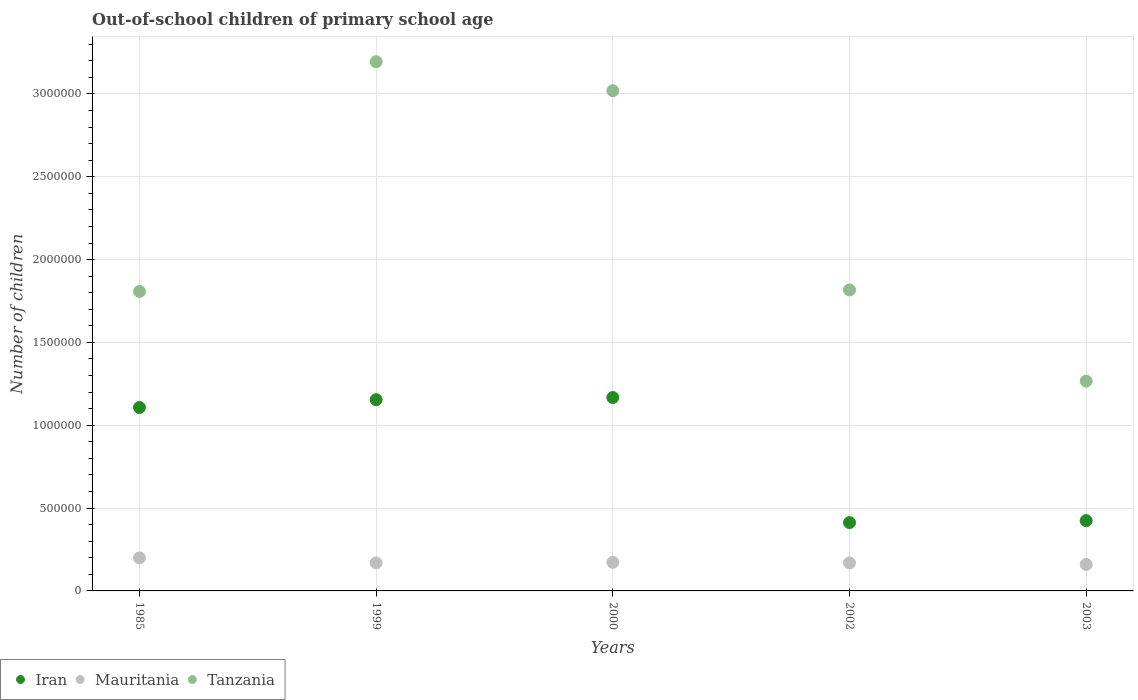How many different coloured dotlines are there?
Offer a very short reply. 3. What is the number of out-of-school children in Mauritania in 2000?
Make the answer very short. 1.73e+05. Across all years, what is the maximum number of out-of-school children in Iran?
Your response must be concise. 1.17e+06. Across all years, what is the minimum number of out-of-school children in Tanzania?
Offer a terse response. 1.27e+06. In which year was the number of out-of-school children in Tanzania maximum?
Your response must be concise. 1999. In which year was the number of out-of-school children in Iran minimum?
Give a very brief answer. 2002. What is the total number of out-of-school children in Mauritania in the graph?
Keep it short and to the point. 8.70e+05. What is the difference between the number of out-of-school children in Iran in 1985 and that in 2002?
Offer a very short reply. 6.95e+05. What is the difference between the number of out-of-school children in Tanzania in 1985 and the number of out-of-school children in Iran in 2002?
Give a very brief answer. 1.40e+06. What is the average number of out-of-school children in Mauritania per year?
Your answer should be compact. 1.74e+05. In the year 2002, what is the difference between the number of out-of-school children in Tanzania and number of out-of-school children in Iran?
Your response must be concise. 1.40e+06. In how many years, is the number of out-of-school children in Tanzania greater than 300000?
Make the answer very short. 5. What is the ratio of the number of out-of-school children in Mauritania in 1985 to that in 2002?
Your answer should be compact. 1.18. Is the difference between the number of out-of-school children in Tanzania in 1985 and 2002 greater than the difference between the number of out-of-school children in Iran in 1985 and 2002?
Provide a short and direct response. No. What is the difference between the highest and the second highest number of out-of-school children in Tanzania?
Give a very brief answer. 1.75e+05. What is the difference between the highest and the lowest number of out-of-school children in Mauritania?
Keep it short and to the point. 3.96e+04. Is the number of out-of-school children in Iran strictly greater than the number of out-of-school children in Tanzania over the years?
Give a very brief answer. No. How many years are there in the graph?
Make the answer very short. 5. What is the difference between two consecutive major ticks on the Y-axis?
Your answer should be compact. 5.00e+05. Does the graph contain grids?
Keep it short and to the point. Yes. Where does the legend appear in the graph?
Provide a short and direct response. Bottom left. What is the title of the graph?
Ensure brevity in your answer.  Out-of-school children of primary school age. Does "South Asia" appear as one of the legend labels in the graph?
Your answer should be very brief. No. What is the label or title of the X-axis?
Your response must be concise. Years. What is the label or title of the Y-axis?
Offer a very short reply. Number of children. What is the Number of children of Iran in 1985?
Your response must be concise. 1.11e+06. What is the Number of children of Mauritania in 1985?
Your answer should be very brief. 1.99e+05. What is the Number of children of Tanzania in 1985?
Ensure brevity in your answer.  1.81e+06. What is the Number of children of Iran in 1999?
Provide a succinct answer. 1.15e+06. What is the Number of children in Mauritania in 1999?
Make the answer very short. 1.69e+05. What is the Number of children of Tanzania in 1999?
Make the answer very short. 3.19e+06. What is the Number of children of Iran in 2000?
Make the answer very short. 1.17e+06. What is the Number of children of Mauritania in 2000?
Give a very brief answer. 1.73e+05. What is the Number of children in Tanzania in 2000?
Your answer should be very brief. 3.02e+06. What is the Number of children of Iran in 2002?
Provide a succinct answer. 4.12e+05. What is the Number of children of Mauritania in 2002?
Ensure brevity in your answer.  1.69e+05. What is the Number of children of Tanzania in 2002?
Offer a terse response. 1.82e+06. What is the Number of children of Iran in 2003?
Your answer should be compact. 4.24e+05. What is the Number of children of Mauritania in 2003?
Your response must be concise. 1.60e+05. What is the Number of children in Tanzania in 2003?
Your answer should be very brief. 1.27e+06. Across all years, what is the maximum Number of children in Iran?
Give a very brief answer. 1.17e+06. Across all years, what is the maximum Number of children of Mauritania?
Your answer should be very brief. 1.99e+05. Across all years, what is the maximum Number of children in Tanzania?
Provide a succinct answer. 3.19e+06. Across all years, what is the minimum Number of children in Iran?
Make the answer very short. 4.12e+05. Across all years, what is the minimum Number of children in Mauritania?
Your answer should be very brief. 1.60e+05. Across all years, what is the minimum Number of children in Tanzania?
Give a very brief answer. 1.27e+06. What is the total Number of children of Iran in the graph?
Keep it short and to the point. 4.27e+06. What is the total Number of children of Mauritania in the graph?
Your response must be concise. 8.70e+05. What is the total Number of children of Tanzania in the graph?
Give a very brief answer. 1.11e+07. What is the difference between the Number of children of Iran in 1985 and that in 1999?
Your answer should be compact. -4.70e+04. What is the difference between the Number of children in Mauritania in 1985 and that in 1999?
Your response must be concise. 3.02e+04. What is the difference between the Number of children in Tanzania in 1985 and that in 1999?
Offer a very short reply. -1.39e+06. What is the difference between the Number of children of Iran in 1985 and that in 2000?
Keep it short and to the point. -5.99e+04. What is the difference between the Number of children of Mauritania in 1985 and that in 2000?
Your answer should be very brief. 2.66e+04. What is the difference between the Number of children of Tanzania in 1985 and that in 2000?
Keep it short and to the point. -1.21e+06. What is the difference between the Number of children of Iran in 1985 and that in 2002?
Make the answer very short. 6.95e+05. What is the difference between the Number of children in Mauritania in 1985 and that in 2002?
Offer a terse response. 3.00e+04. What is the difference between the Number of children of Tanzania in 1985 and that in 2002?
Offer a terse response. -9045. What is the difference between the Number of children of Iran in 1985 and that in 2003?
Provide a short and direct response. 6.83e+05. What is the difference between the Number of children of Mauritania in 1985 and that in 2003?
Make the answer very short. 3.96e+04. What is the difference between the Number of children in Tanzania in 1985 and that in 2003?
Give a very brief answer. 5.41e+05. What is the difference between the Number of children in Iran in 1999 and that in 2000?
Your answer should be compact. -1.30e+04. What is the difference between the Number of children in Mauritania in 1999 and that in 2000?
Make the answer very short. -3592. What is the difference between the Number of children in Tanzania in 1999 and that in 2000?
Give a very brief answer. 1.75e+05. What is the difference between the Number of children in Iran in 1999 and that in 2002?
Provide a succinct answer. 7.42e+05. What is the difference between the Number of children in Mauritania in 1999 and that in 2002?
Keep it short and to the point. -176. What is the difference between the Number of children of Tanzania in 1999 and that in 2002?
Keep it short and to the point. 1.38e+06. What is the difference between the Number of children of Iran in 1999 and that in 2003?
Offer a very short reply. 7.30e+05. What is the difference between the Number of children of Mauritania in 1999 and that in 2003?
Give a very brief answer. 9480. What is the difference between the Number of children of Tanzania in 1999 and that in 2003?
Give a very brief answer. 1.93e+06. What is the difference between the Number of children of Iran in 2000 and that in 2002?
Your answer should be very brief. 7.55e+05. What is the difference between the Number of children in Mauritania in 2000 and that in 2002?
Keep it short and to the point. 3416. What is the difference between the Number of children of Tanzania in 2000 and that in 2002?
Keep it short and to the point. 1.20e+06. What is the difference between the Number of children in Iran in 2000 and that in 2003?
Make the answer very short. 7.43e+05. What is the difference between the Number of children of Mauritania in 2000 and that in 2003?
Ensure brevity in your answer.  1.31e+04. What is the difference between the Number of children in Tanzania in 2000 and that in 2003?
Provide a succinct answer. 1.75e+06. What is the difference between the Number of children of Iran in 2002 and that in 2003?
Keep it short and to the point. -1.18e+04. What is the difference between the Number of children of Mauritania in 2002 and that in 2003?
Your answer should be compact. 9656. What is the difference between the Number of children in Tanzania in 2002 and that in 2003?
Ensure brevity in your answer.  5.50e+05. What is the difference between the Number of children in Iran in 1985 and the Number of children in Mauritania in 1999?
Ensure brevity in your answer.  9.38e+05. What is the difference between the Number of children of Iran in 1985 and the Number of children of Tanzania in 1999?
Your answer should be very brief. -2.09e+06. What is the difference between the Number of children in Mauritania in 1985 and the Number of children in Tanzania in 1999?
Offer a terse response. -3.00e+06. What is the difference between the Number of children in Iran in 1985 and the Number of children in Mauritania in 2000?
Ensure brevity in your answer.  9.35e+05. What is the difference between the Number of children in Iran in 1985 and the Number of children in Tanzania in 2000?
Your answer should be compact. -1.91e+06. What is the difference between the Number of children in Mauritania in 1985 and the Number of children in Tanzania in 2000?
Give a very brief answer. -2.82e+06. What is the difference between the Number of children of Iran in 1985 and the Number of children of Mauritania in 2002?
Give a very brief answer. 9.38e+05. What is the difference between the Number of children of Iran in 1985 and the Number of children of Tanzania in 2002?
Keep it short and to the point. -7.09e+05. What is the difference between the Number of children in Mauritania in 1985 and the Number of children in Tanzania in 2002?
Your answer should be very brief. -1.62e+06. What is the difference between the Number of children in Iran in 1985 and the Number of children in Mauritania in 2003?
Your answer should be compact. 9.48e+05. What is the difference between the Number of children in Iran in 1985 and the Number of children in Tanzania in 2003?
Give a very brief answer. -1.59e+05. What is the difference between the Number of children in Mauritania in 1985 and the Number of children in Tanzania in 2003?
Provide a succinct answer. -1.07e+06. What is the difference between the Number of children in Iran in 1999 and the Number of children in Mauritania in 2000?
Make the answer very short. 9.82e+05. What is the difference between the Number of children of Iran in 1999 and the Number of children of Tanzania in 2000?
Provide a succinct answer. -1.86e+06. What is the difference between the Number of children of Mauritania in 1999 and the Number of children of Tanzania in 2000?
Keep it short and to the point. -2.85e+06. What is the difference between the Number of children in Iran in 1999 and the Number of children in Mauritania in 2002?
Give a very brief answer. 9.85e+05. What is the difference between the Number of children of Iran in 1999 and the Number of children of Tanzania in 2002?
Provide a short and direct response. -6.62e+05. What is the difference between the Number of children in Mauritania in 1999 and the Number of children in Tanzania in 2002?
Provide a succinct answer. -1.65e+06. What is the difference between the Number of children of Iran in 1999 and the Number of children of Mauritania in 2003?
Provide a short and direct response. 9.95e+05. What is the difference between the Number of children in Iran in 1999 and the Number of children in Tanzania in 2003?
Offer a terse response. -1.12e+05. What is the difference between the Number of children of Mauritania in 1999 and the Number of children of Tanzania in 2003?
Keep it short and to the point. -1.10e+06. What is the difference between the Number of children of Iran in 2000 and the Number of children of Mauritania in 2002?
Give a very brief answer. 9.98e+05. What is the difference between the Number of children of Iran in 2000 and the Number of children of Tanzania in 2002?
Keep it short and to the point. -6.49e+05. What is the difference between the Number of children in Mauritania in 2000 and the Number of children in Tanzania in 2002?
Offer a very short reply. -1.64e+06. What is the difference between the Number of children in Iran in 2000 and the Number of children in Mauritania in 2003?
Give a very brief answer. 1.01e+06. What is the difference between the Number of children of Iran in 2000 and the Number of children of Tanzania in 2003?
Provide a succinct answer. -9.90e+04. What is the difference between the Number of children of Mauritania in 2000 and the Number of children of Tanzania in 2003?
Keep it short and to the point. -1.09e+06. What is the difference between the Number of children of Iran in 2002 and the Number of children of Mauritania in 2003?
Your answer should be very brief. 2.53e+05. What is the difference between the Number of children of Iran in 2002 and the Number of children of Tanzania in 2003?
Offer a very short reply. -8.54e+05. What is the difference between the Number of children in Mauritania in 2002 and the Number of children in Tanzania in 2003?
Make the answer very short. -1.10e+06. What is the average Number of children of Iran per year?
Give a very brief answer. 8.53e+05. What is the average Number of children of Mauritania per year?
Your answer should be very brief. 1.74e+05. What is the average Number of children in Tanzania per year?
Ensure brevity in your answer.  2.22e+06. In the year 1985, what is the difference between the Number of children of Iran and Number of children of Mauritania?
Provide a short and direct response. 9.08e+05. In the year 1985, what is the difference between the Number of children of Iran and Number of children of Tanzania?
Your response must be concise. -7.00e+05. In the year 1985, what is the difference between the Number of children of Mauritania and Number of children of Tanzania?
Offer a terse response. -1.61e+06. In the year 1999, what is the difference between the Number of children of Iran and Number of children of Mauritania?
Provide a short and direct response. 9.85e+05. In the year 1999, what is the difference between the Number of children in Iran and Number of children in Tanzania?
Ensure brevity in your answer.  -2.04e+06. In the year 1999, what is the difference between the Number of children of Mauritania and Number of children of Tanzania?
Provide a short and direct response. -3.03e+06. In the year 2000, what is the difference between the Number of children of Iran and Number of children of Mauritania?
Ensure brevity in your answer.  9.95e+05. In the year 2000, what is the difference between the Number of children of Iran and Number of children of Tanzania?
Provide a short and direct response. -1.85e+06. In the year 2000, what is the difference between the Number of children in Mauritania and Number of children in Tanzania?
Your response must be concise. -2.85e+06. In the year 2002, what is the difference between the Number of children of Iran and Number of children of Mauritania?
Your answer should be very brief. 2.43e+05. In the year 2002, what is the difference between the Number of children of Iran and Number of children of Tanzania?
Keep it short and to the point. -1.40e+06. In the year 2002, what is the difference between the Number of children in Mauritania and Number of children in Tanzania?
Offer a very short reply. -1.65e+06. In the year 2003, what is the difference between the Number of children in Iran and Number of children in Mauritania?
Offer a very short reply. 2.65e+05. In the year 2003, what is the difference between the Number of children of Iran and Number of children of Tanzania?
Provide a short and direct response. -8.42e+05. In the year 2003, what is the difference between the Number of children of Mauritania and Number of children of Tanzania?
Your answer should be very brief. -1.11e+06. What is the ratio of the Number of children of Iran in 1985 to that in 1999?
Provide a succinct answer. 0.96. What is the ratio of the Number of children of Mauritania in 1985 to that in 1999?
Ensure brevity in your answer.  1.18. What is the ratio of the Number of children of Tanzania in 1985 to that in 1999?
Provide a succinct answer. 0.57. What is the ratio of the Number of children in Iran in 1985 to that in 2000?
Give a very brief answer. 0.95. What is the ratio of the Number of children of Mauritania in 1985 to that in 2000?
Give a very brief answer. 1.15. What is the ratio of the Number of children in Tanzania in 1985 to that in 2000?
Your answer should be very brief. 0.6. What is the ratio of the Number of children in Iran in 1985 to that in 2002?
Give a very brief answer. 2.69. What is the ratio of the Number of children in Mauritania in 1985 to that in 2002?
Keep it short and to the point. 1.18. What is the ratio of the Number of children in Iran in 1985 to that in 2003?
Offer a terse response. 2.61. What is the ratio of the Number of children of Mauritania in 1985 to that in 2003?
Ensure brevity in your answer.  1.25. What is the ratio of the Number of children of Tanzania in 1985 to that in 2003?
Keep it short and to the point. 1.43. What is the ratio of the Number of children of Iran in 1999 to that in 2000?
Offer a very short reply. 0.99. What is the ratio of the Number of children of Mauritania in 1999 to that in 2000?
Provide a short and direct response. 0.98. What is the ratio of the Number of children in Tanzania in 1999 to that in 2000?
Your answer should be very brief. 1.06. What is the ratio of the Number of children in Iran in 1999 to that in 2002?
Ensure brevity in your answer.  2.8. What is the ratio of the Number of children of Tanzania in 1999 to that in 2002?
Offer a terse response. 1.76. What is the ratio of the Number of children of Iran in 1999 to that in 2003?
Keep it short and to the point. 2.72. What is the ratio of the Number of children in Mauritania in 1999 to that in 2003?
Offer a very short reply. 1.06. What is the ratio of the Number of children in Tanzania in 1999 to that in 2003?
Keep it short and to the point. 2.52. What is the ratio of the Number of children in Iran in 2000 to that in 2002?
Make the answer very short. 2.83. What is the ratio of the Number of children of Mauritania in 2000 to that in 2002?
Your answer should be compact. 1.02. What is the ratio of the Number of children in Tanzania in 2000 to that in 2002?
Offer a very short reply. 1.66. What is the ratio of the Number of children of Iran in 2000 to that in 2003?
Give a very brief answer. 2.75. What is the ratio of the Number of children of Mauritania in 2000 to that in 2003?
Your answer should be very brief. 1.08. What is the ratio of the Number of children in Tanzania in 2000 to that in 2003?
Your response must be concise. 2.38. What is the ratio of the Number of children of Iran in 2002 to that in 2003?
Provide a succinct answer. 0.97. What is the ratio of the Number of children of Mauritania in 2002 to that in 2003?
Offer a terse response. 1.06. What is the ratio of the Number of children of Tanzania in 2002 to that in 2003?
Make the answer very short. 1.43. What is the difference between the highest and the second highest Number of children of Iran?
Provide a short and direct response. 1.30e+04. What is the difference between the highest and the second highest Number of children in Mauritania?
Your response must be concise. 2.66e+04. What is the difference between the highest and the second highest Number of children of Tanzania?
Your response must be concise. 1.75e+05. What is the difference between the highest and the lowest Number of children in Iran?
Provide a succinct answer. 7.55e+05. What is the difference between the highest and the lowest Number of children in Mauritania?
Make the answer very short. 3.96e+04. What is the difference between the highest and the lowest Number of children of Tanzania?
Your answer should be very brief. 1.93e+06. 